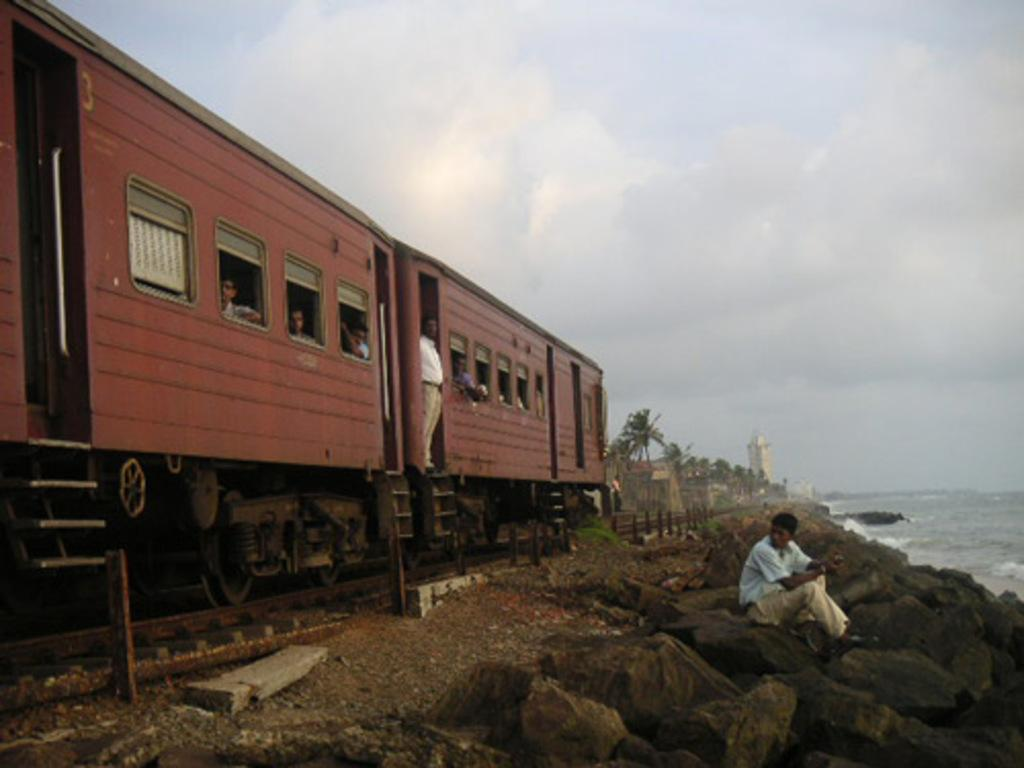What is the person in the image doing? There is a person sitting on the rocks in the image. What can be seen on the right side of the image? There is water visible at the right side of the image. What is located on the left side of the image? There is a train at the left side of the image. Are there any people inside the train? Yes, people are present in the train. What type of natural scenery is visible in the background? There are trees visible in the background. What type of man-made structures can be seen in the background? There are buildings visible in the background. What is the thumb doing in the image? There is no thumb present in the image. What is the limit of the top in the image? The image does not have a limit or a top, as it is a two-dimensional representation. 